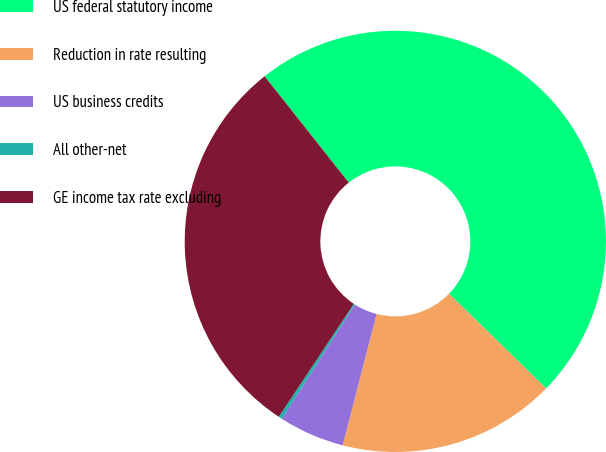Convert chart. <chart><loc_0><loc_0><loc_500><loc_500><pie_chart><fcel>US federal statutory income<fcel>Reduction in rate resulting<fcel>US business credits<fcel>All other-net<fcel>GE income tax rate excluding<nl><fcel>47.96%<fcel>16.72%<fcel>5.04%<fcel>0.27%<fcel>30.01%<nl></chart> 